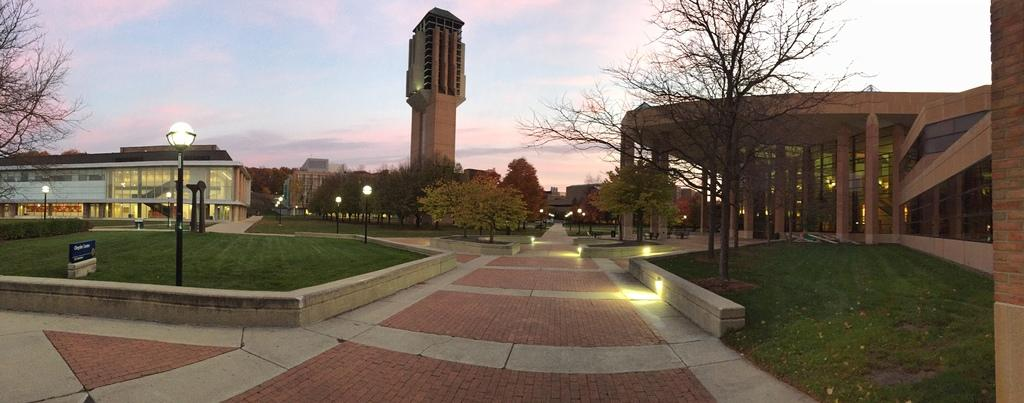What structures are present in the image? There are poles, lights, trees, buildings, and grass in the image. What type of vegetation can be seen in the image? There are trees in the image. What is the background of the image? The sky is visible in the background of the image. What might be used to illuminate the area in the image? The lights in the image might be used to illuminate the area. What is the condition of the foot in the image? There is no foot present in the image. How does the sleep affect the poles in the image? There is no sleep present in the image, and the poles are stationary structures. 